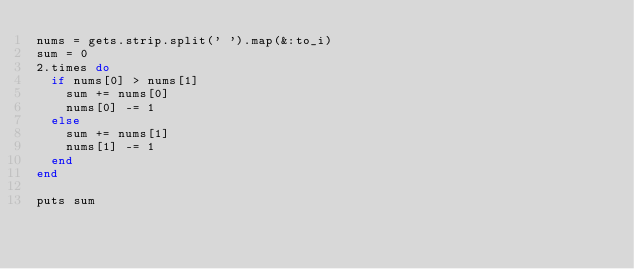<code> <loc_0><loc_0><loc_500><loc_500><_Ruby_>nums = gets.strip.split(' ').map(&:to_i)
sum = 0
2.times do
  if nums[0] > nums[1]
    sum += nums[0]
    nums[0] -= 1
  else
    sum += nums[1]
    nums[1] -= 1
  end
end

puts sum
</code> 